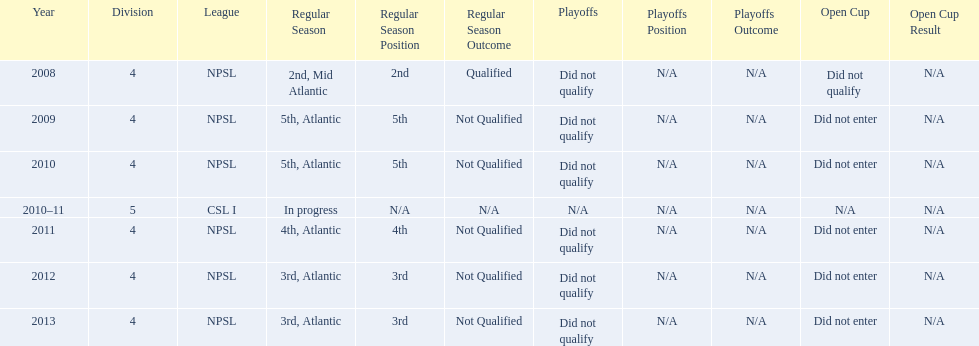Could you parse the entire table as a dict? {'header': ['Year', 'Division', 'League', 'Regular Season', 'Regular Season Position', 'Regular Season Outcome', 'Playoffs', 'Playoffs Position', 'Playoffs Outcome', 'Open Cup', 'Open Cup Result'], 'rows': [['2008', '4', 'NPSL', '2nd, Mid Atlantic', '2nd', 'Qualified', 'Did not qualify', 'N/A', 'N/A', 'Did not qualify', 'N/A'], ['2009', '4', 'NPSL', '5th, Atlantic', '5th', 'Not Qualified', 'Did not qualify', 'N/A', 'N/A', 'Did not enter', 'N/A'], ['2010', '4', 'NPSL', '5th, Atlantic', '5th', 'Not Qualified', 'Did not qualify', 'N/A', 'N/A', 'Did not enter', 'N/A'], ['2010–11', '5', 'CSL I', 'In progress', 'N/A', 'N/A', 'N/A', 'N/A', 'N/A', 'N/A', 'N/A'], ['2011', '4', 'NPSL', '4th, Atlantic', '4th', 'Not Qualified', 'Did not qualify', 'N/A', 'N/A', 'Did not enter', 'N/A'], ['2012', '4', 'NPSL', '3rd, Atlantic', '3rd', 'Not Qualified', 'Did not qualify', 'N/A', 'N/A', 'Did not enter', 'N/A'], ['2013', '4', 'NPSL', '3rd, Atlantic', '3rd', 'Not Qualified', 'Did not qualify', 'N/A', 'N/A', 'Did not enter', 'N/A']]} What is the only year that is n/a? 2010-11. 